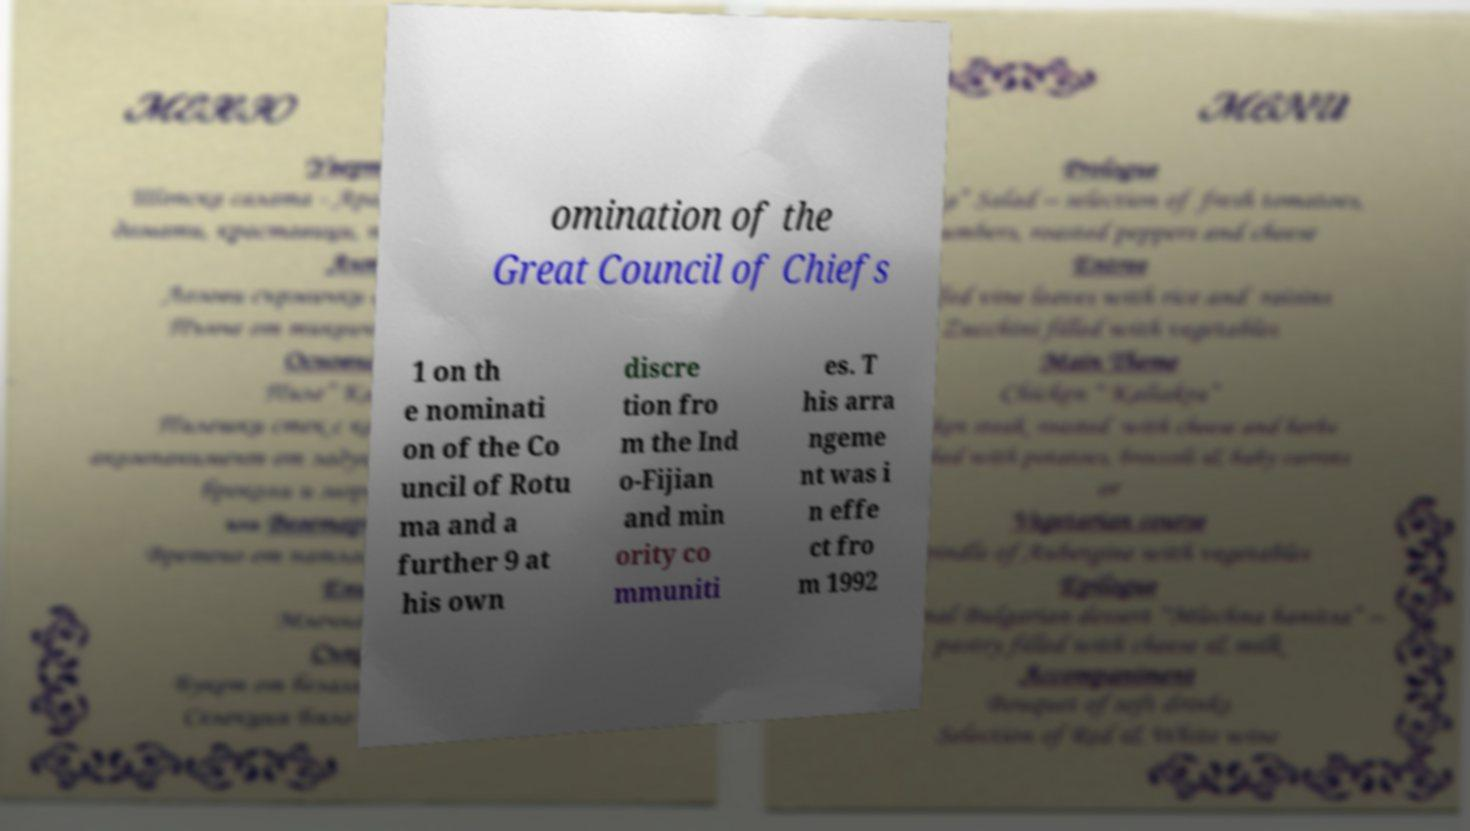For documentation purposes, I need the text within this image transcribed. Could you provide that? omination of the Great Council of Chiefs 1 on th e nominati on of the Co uncil of Rotu ma and a further 9 at his own discre tion fro m the Ind o-Fijian and min ority co mmuniti es. T his arra ngeme nt was i n effe ct fro m 1992 